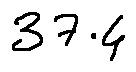Convert formula to latex. <formula><loc_0><loc_0><loc_500><loc_500>3 7 . 4</formula> 